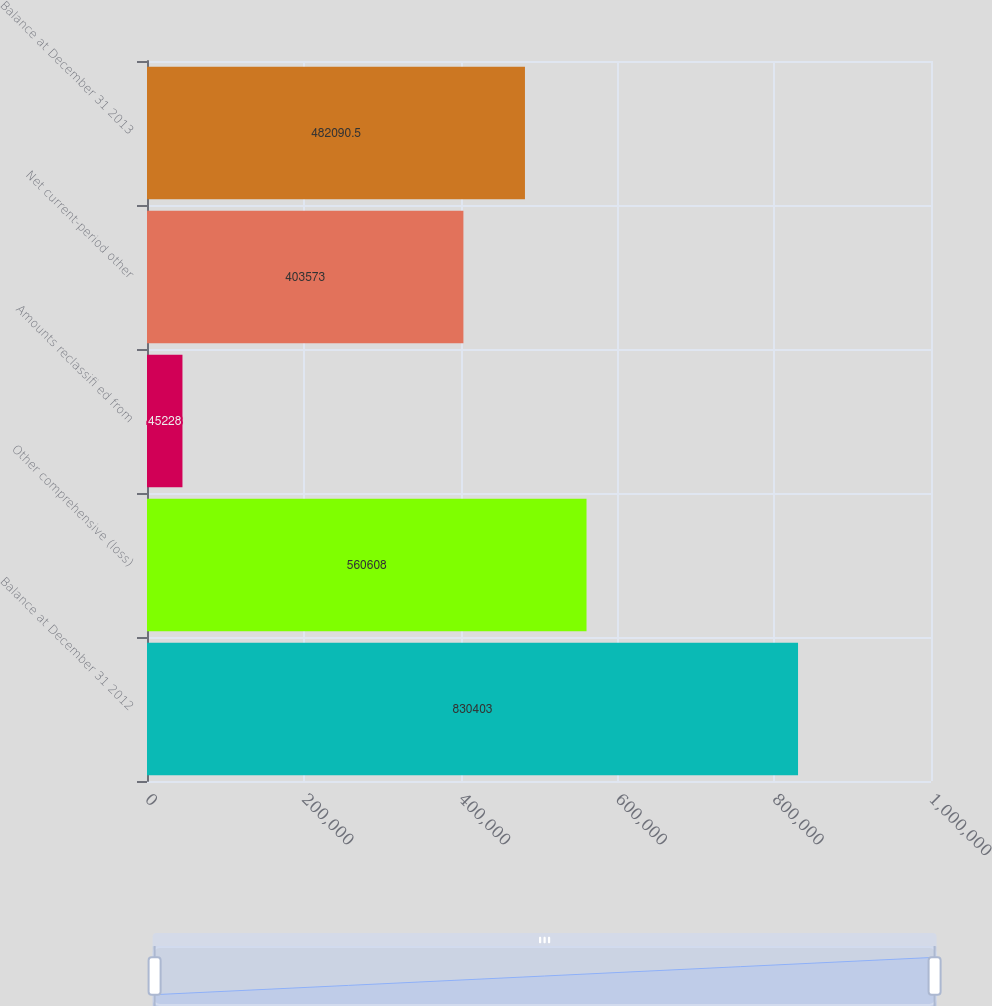<chart> <loc_0><loc_0><loc_500><loc_500><bar_chart><fcel>Balance at December 31 2012<fcel>Other comprehensive (loss)<fcel>Amounts reclassifi ed from<fcel>Net current-period other<fcel>Balance at December 31 2013<nl><fcel>830403<fcel>560608<fcel>45228<fcel>403573<fcel>482090<nl></chart> 